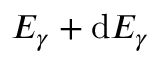<formula> <loc_0><loc_0><loc_500><loc_500>E _ { \gamma } + d E _ { \gamma }</formula> 